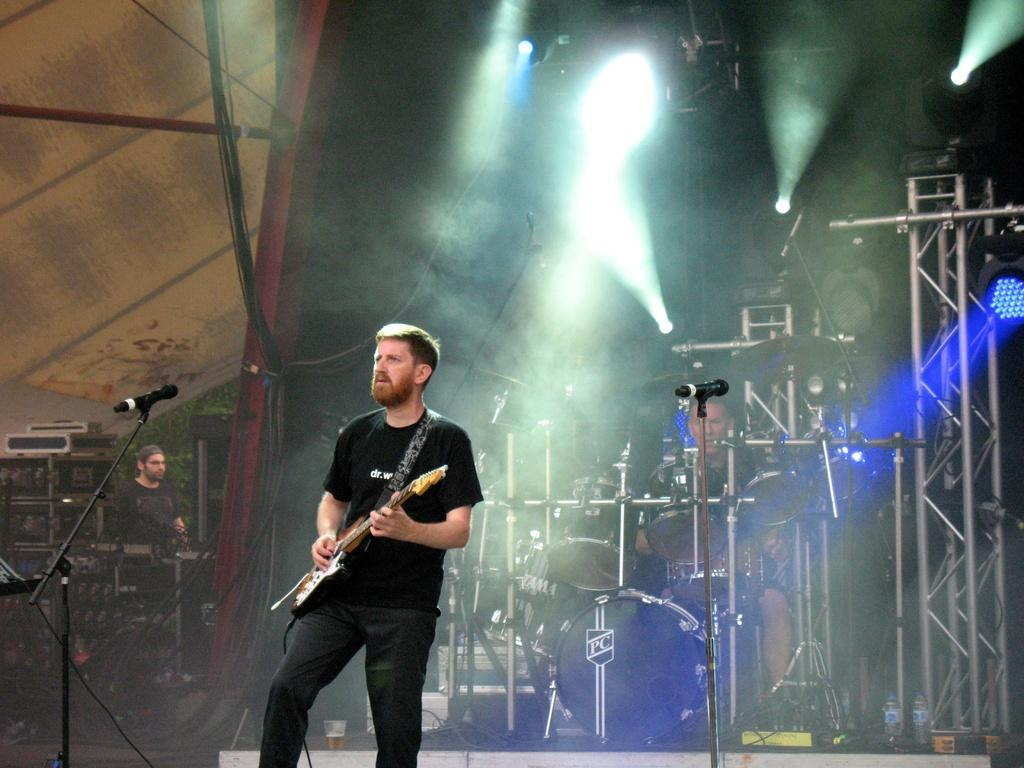What is the main subject of the image? There is a man standing in the center of the image. What is the man in the center doing? The man is playing a guitar. Are there any other musicians in the image? Yes, there is a man playing a snare drum in the background of the image. Can you describe the lighting arrangement in the image? Unfortunately, the provided facts do not mention any details about the lighting arrangement. What type of banana is being used as a rake in the image? There is no banana or rake present in the image. 